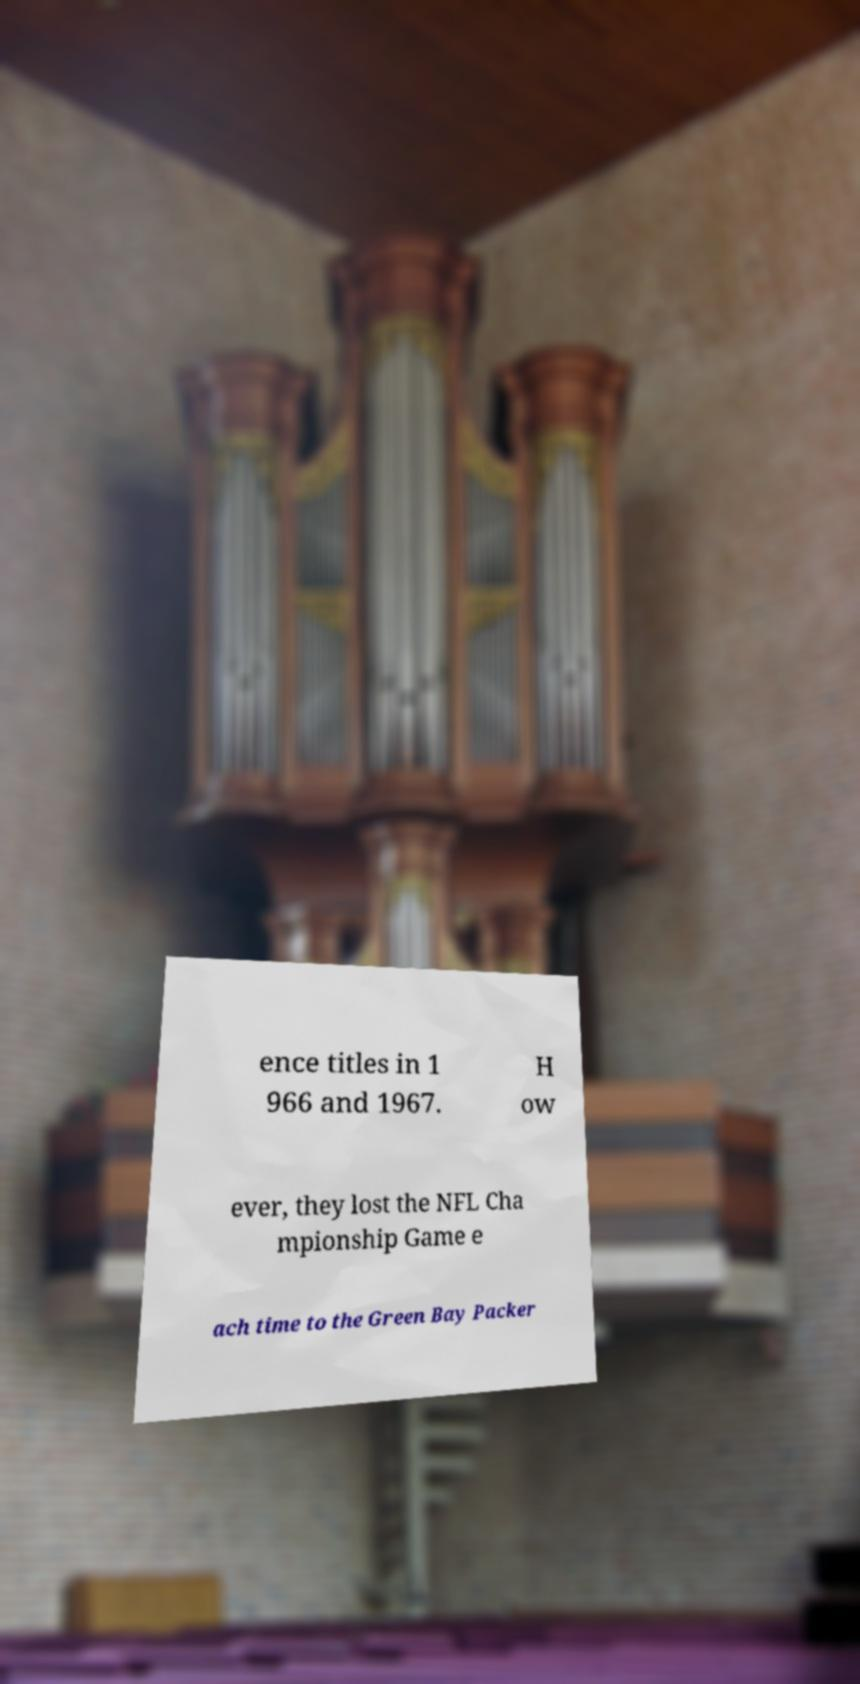There's text embedded in this image that I need extracted. Can you transcribe it verbatim? ence titles in 1 966 and 1967. H ow ever, they lost the NFL Cha mpionship Game e ach time to the Green Bay Packer 